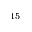<formula> <loc_0><loc_0><loc_500><loc_500>^ { 1 5 }</formula> 